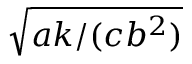<formula> <loc_0><loc_0><loc_500><loc_500>\sqrt { a k / ( c b ^ { 2 } ) }</formula> 